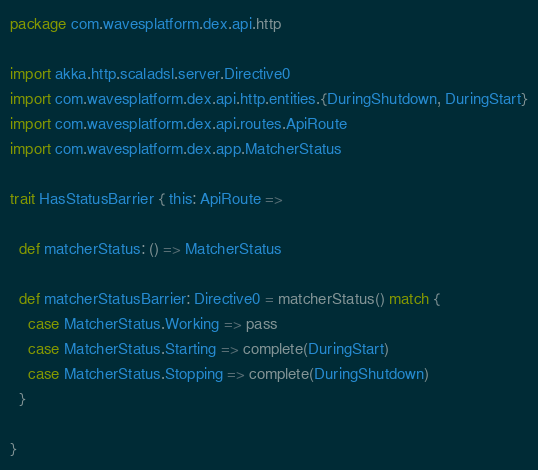Convert code to text. <code><loc_0><loc_0><loc_500><loc_500><_Scala_>package com.wavesplatform.dex.api.http

import akka.http.scaladsl.server.Directive0
import com.wavesplatform.dex.api.http.entities.{DuringShutdown, DuringStart}
import com.wavesplatform.dex.api.routes.ApiRoute
import com.wavesplatform.dex.app.MatcherStatus

trait HasStatusBarrier { this: ApiRoute =>

  def matcherStatus: () => MatcherStatus

  def matcherStatusBarrier: Directive0 = matcherStatus() match {
    case MatcherStatus.Working => pass
    case MatcherStatus.Starting => complete(DuringStart)
    case MatcherStatus.Stopping => complete(DuringShutdown)
  }

}
</code> 